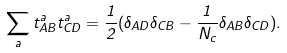Convert formula to latex. <formula><loc_0><loc_0><loc_500><loc_500>\sum _ { a } t ^ { a } _ { A B } t ^ { a } _ { C D } = \frac { 1 } { 2 } ( \delta _ { A D } \delta _ { C B } - \frac { 1 } { N _ { c } } \delta _ { A B } \delta _ { C D } ) .</formula> 